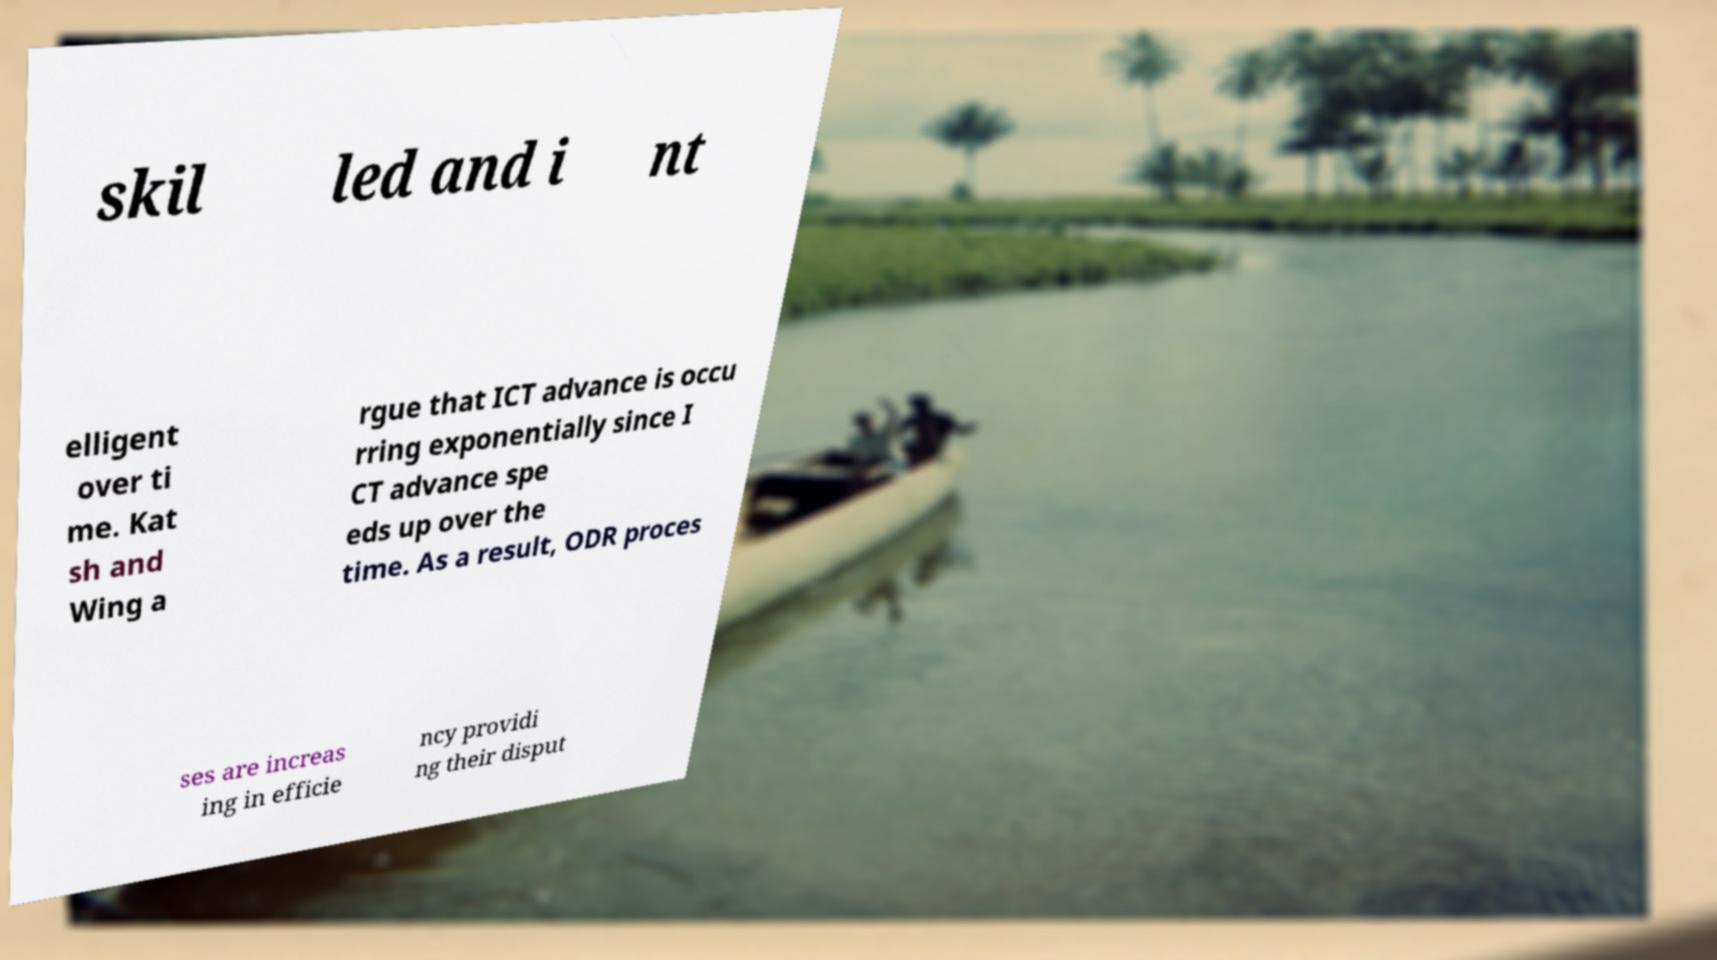Can you read and provide the text displayed in the image?This photo seems to have some interesting text. Can you extract and type it out for me? skil led and i nt elligent over ti me. Kat sh and Wing a rgue that ICT advance is occu rring exponentially since I CT advance spe eds up over the time. As a result, ODR proces ses are increas ing in efficie ncy providi ng their disput 